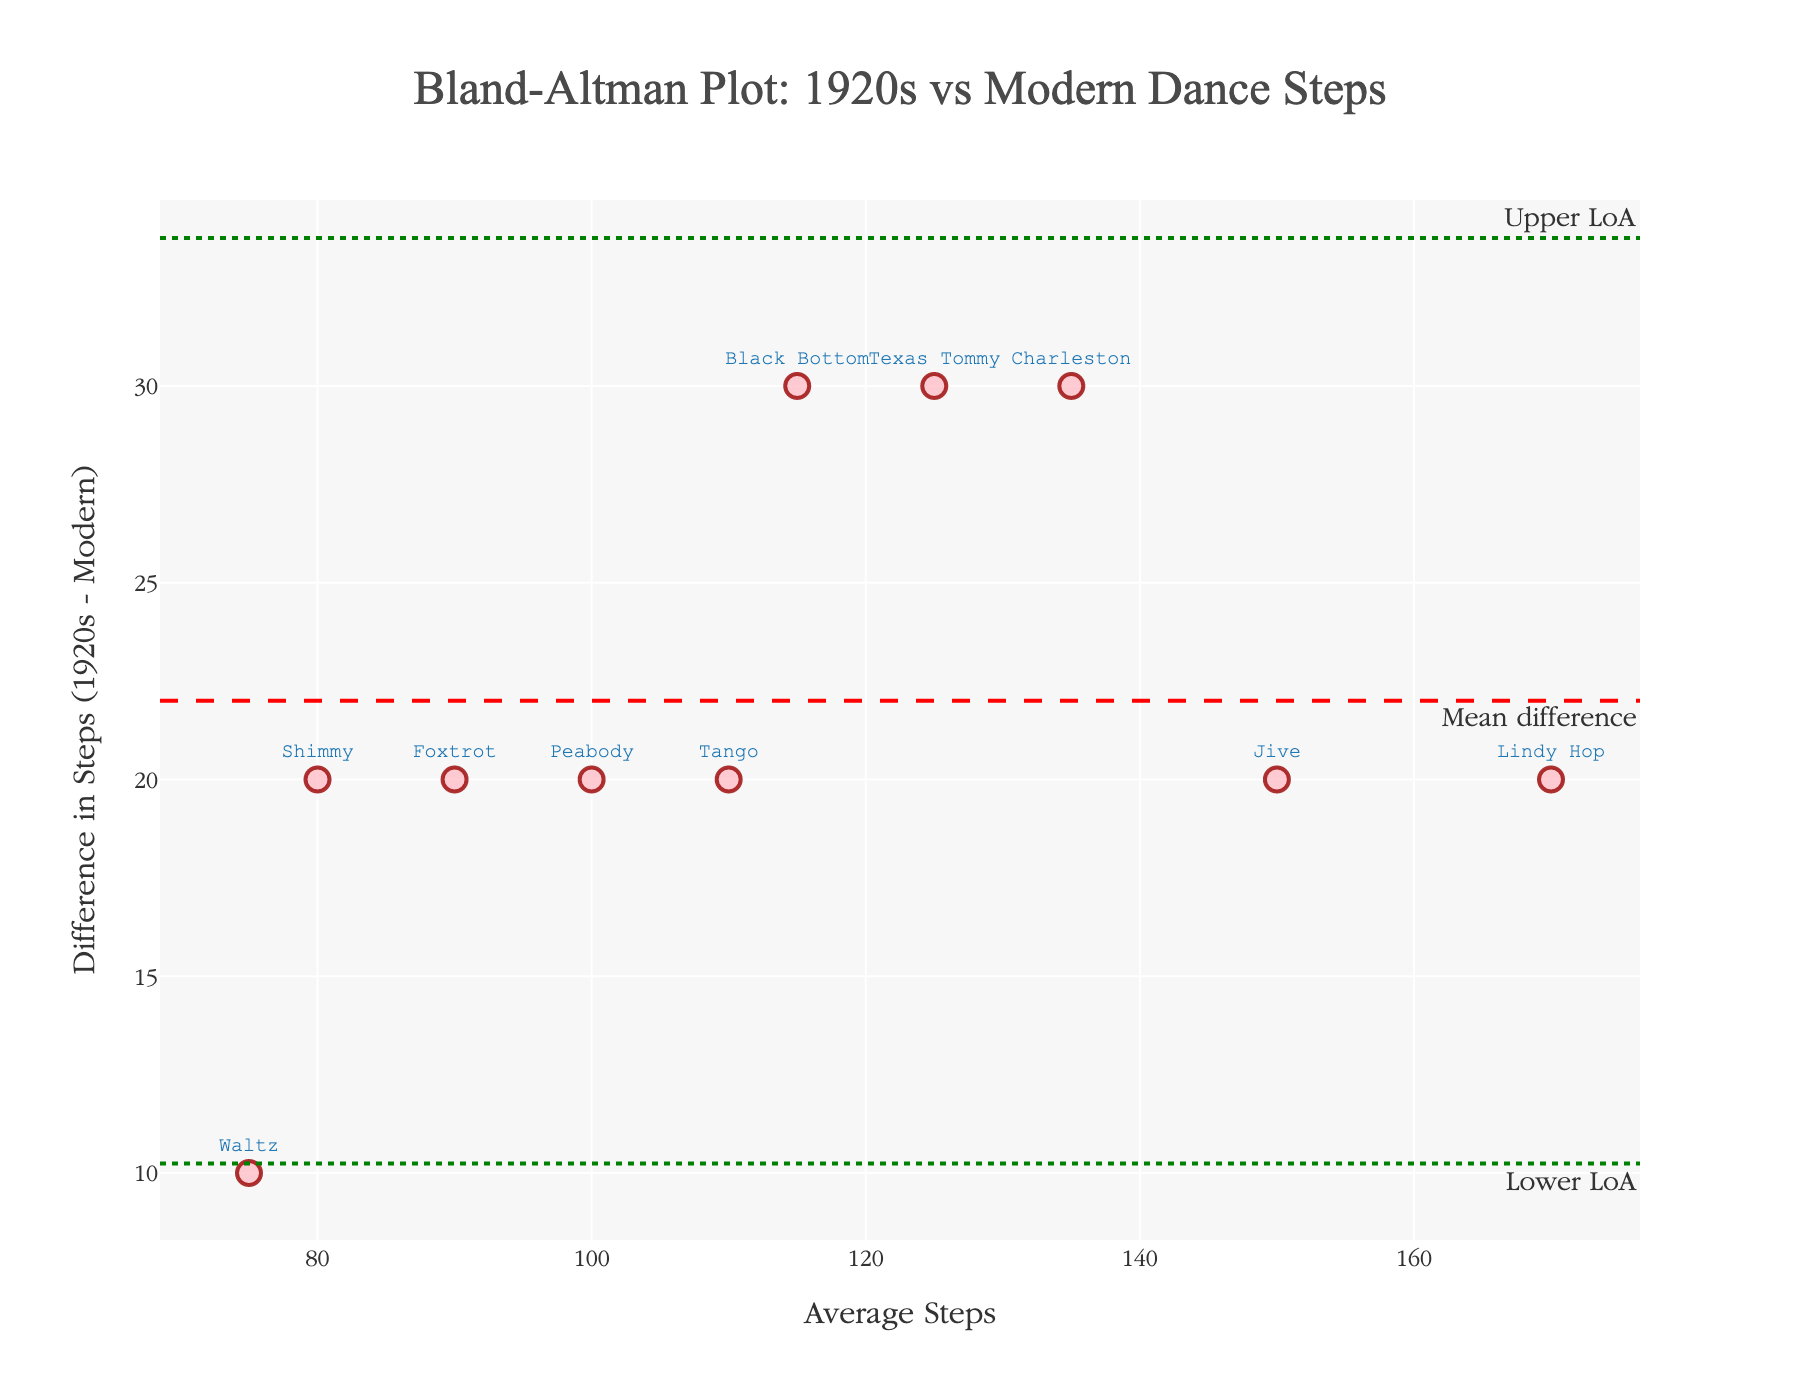What's the title of the plot? The title is displayed prominently at the top of the figure, making it easy to identify.
Answer: Bland-Altman Plot: 1920s vs Modern Dance Steps What are the two types of lines represented by green and red color on the plot? The green lines represent the limits of agreement (Upper LoA and Lower LoA), while the red dashed line represents the mean difference.
Answer: Limits of agreement and mean difference How many different dance types are presented in the plot? By counting the number of marker labels, we can determine the number of data points which represent different dance types.
Answer: 10 Which dance has the largest difference in steps between 1920s and modern? By examining the y-values of the scatter points, we find the largest positive difference which corresponds to the Charleston dance.
Answer: Charleston What's the average number of steps for the Waltz? By looking at the average steps value for the Waltz, we can directly extract the number.
Answer: 75 What is the mean difference in steps between 1920s and modern dances? The red dashed line on the plot represents the mean difference, which is also annotated as "Mean difference".
Answer: -20 What are the values of the limits of agreement? The green dotted lines mark the upper and lower limits of agreement with their corresponding values.
Answer: Upper: 7.84, Lower: -47.84 How does the difference in steps for the Tango compare to the mean difference? The Tango’s difference can be compared to the mean difference by examining its position relative to the red dashed line.
Answer: The Tango's step difference is the same as the mean difference Which dance types fall outside the limits of agreement? We need to identify any markers that are above the upper green line or below the lower green line. No markers fall outside these lines in the plot.
Answer: None What's the difference in steps for the Jive, and does it fall within the limits of agreement? By locating the marker for Jive and measuring its y-axis value, we find the difference and check if it falls within the green lines.
Answer: -20, within the limits 